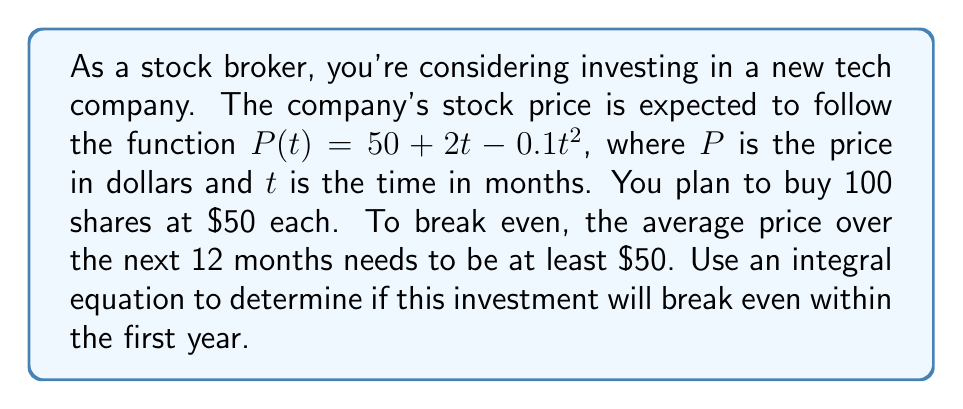Help me with this question. Let's approach this step-by-step:

1) The break-even point occurs when the average price over the 12 months equals the initial price of $50.

2) To find the average price, we need to integrate the price function over the 12-month period and divide by 12:

   $\frac{1}{12} \int_0^{12} P(t) dt = 50$

3) Substituting the given price function:

   $\frac{1}{12} \int_0^{12} (50 + 2t - 0.1t^2) dt = 50$

4) Let's solve the integral:
   
   $\frac{1}{12} [50t + t^2 - \frac{0.1t^3}{3}]_0^{12} = 50$

5) Evaluating the integral:

   $\frac{1}{12} [(50 \cdot 12 + 12^2 - \frac{0.1 \cdot 12^3}{3}) - (0 + 0 - 0)] = 50$

6) Simplifying:

   $\frac{1}{12} [600 + 144 - 57.6] = 50$
   
   $\frac{686.4}{12} = 50$

7) Calculating the result:

   $57.2 = 50$

8) Since the average price ($57.2) is greater than the initial price ($50), the investment will break even within the first year.
Answer: Yes, the investment will break even within the first year. 